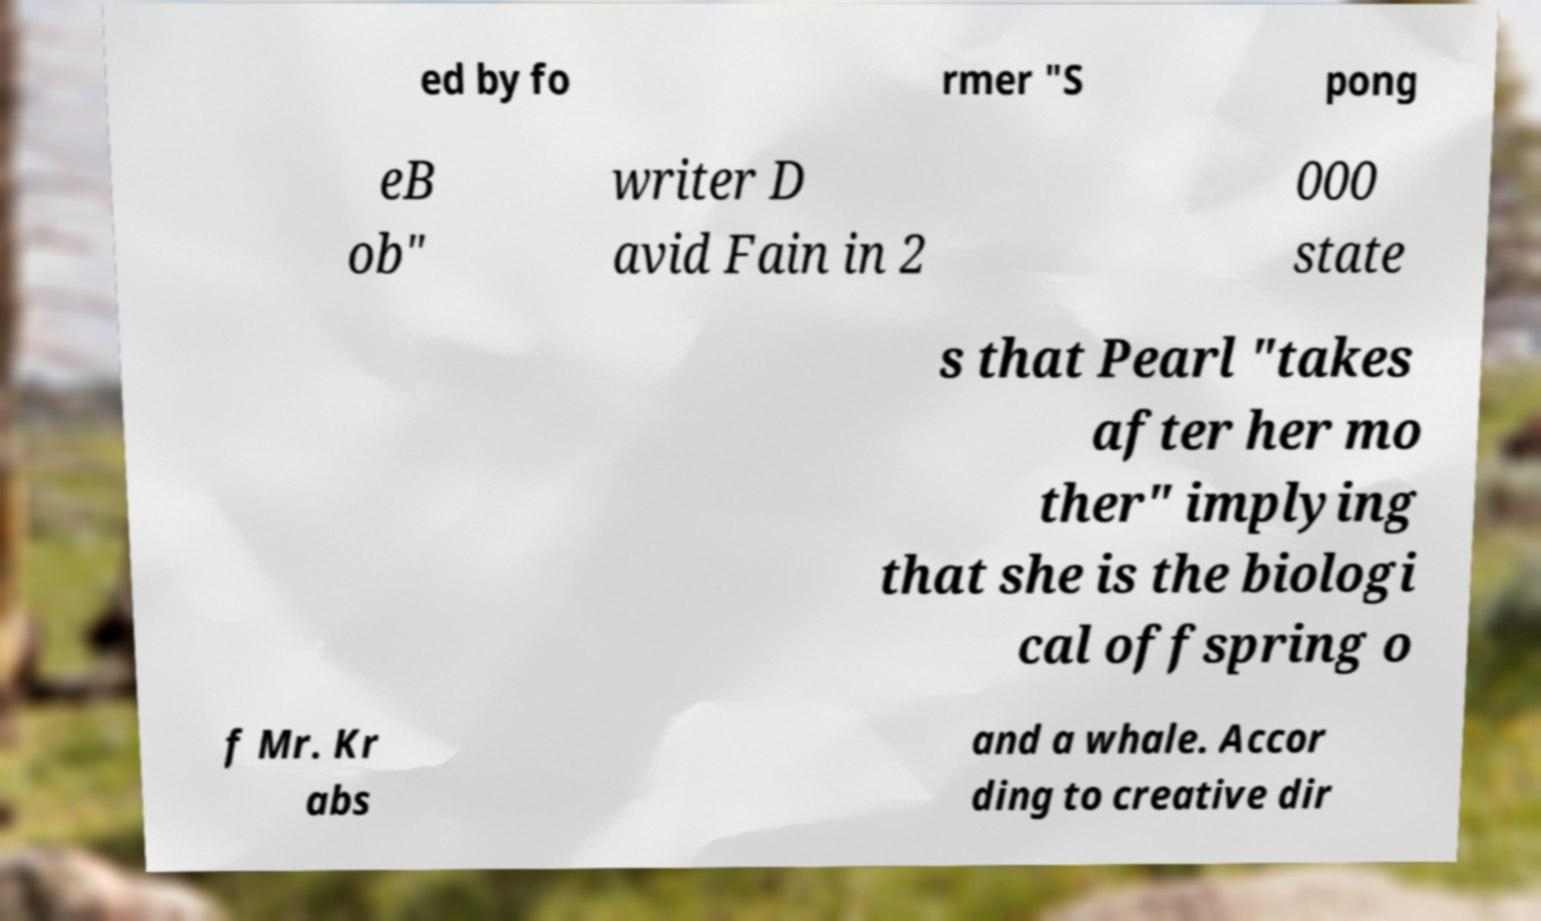Could you assist in decoding the text presented in this image and type it out clearly? ed by fo rmer "S pong eB ob" writer D avid Fain in 2 000 state s that Pearl "takes after her mo ther" implying that she is the biologi cal offspring o f Mr. Kr abs and a whale. Accor ding to creative dir 